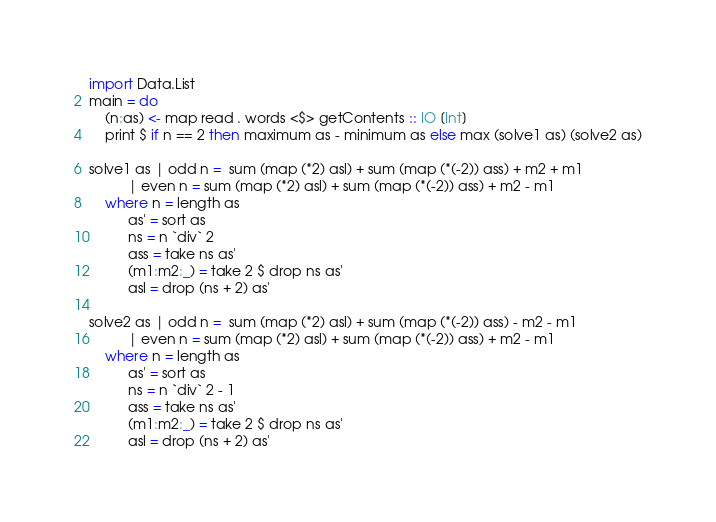Convert code to text. <code><loc_0><loc_0><loc_500><loc_500><_Haskell_>import Data.List
main = do
    (n:as) <- map read . words <$> getContents :: IO [Int]
    print $ if n == 2 then maximum as - minimum as else max (solve1 as) (solve2 as)

solve1 as | odd n =  sum (map (*2) asl) + sum (map (*(-2)) ass) + m2 + m1
          | even n = sum (map (*2) asl) + sum (map (*(-2)) ass) + m2 - m1
    where n = length as
          as' = sort as
          ns = n `div` 2
          ass = take ns as'
          (m1:m2:_) = take 2 $ drop ns as'
          asl = drop (ns + 2) as'

solve2 as | odd n =  sum (map (*2) asl) + sum (map (*(-2)) ass) - m2 - m1
          | even n = sum (map (*2) asl) + sum (map (*(-2)) ass) + m2 - m1
    where n = length as
          as' = sort as
          ns = n `div` 2 - 1
          ass = take ns as'
          (m1:m2:_) = take 2 $ drop ns as'
          asl = drop (ns + 2) as'</code> 